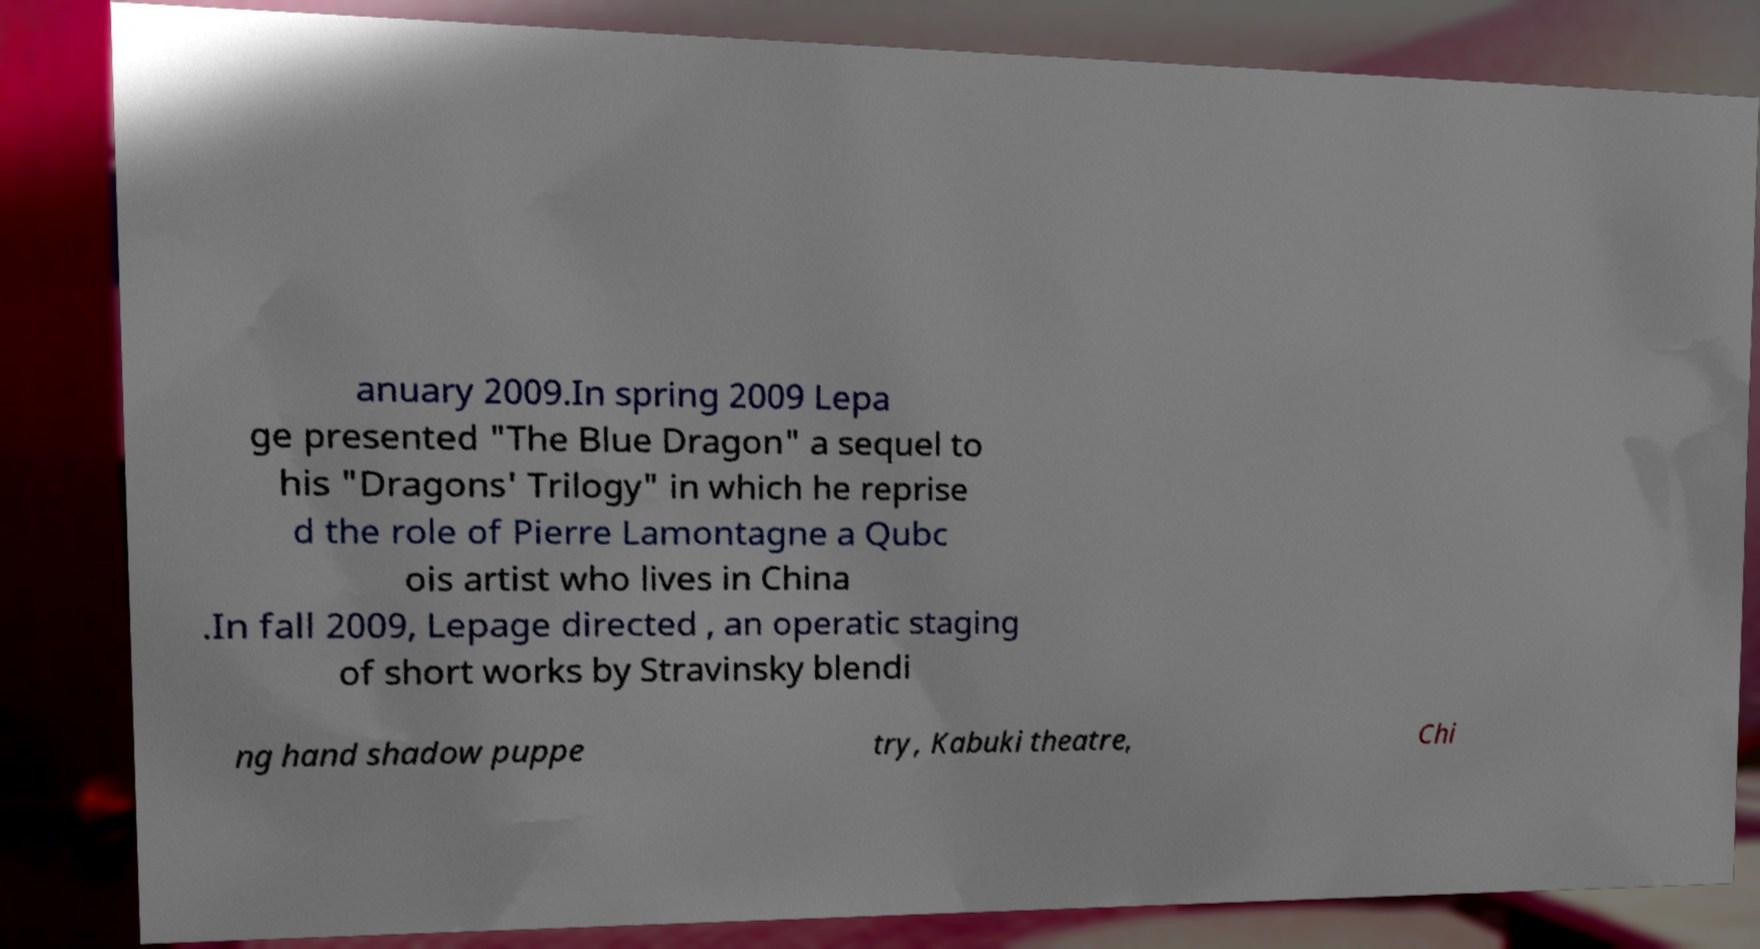Please identify and transcribe the text found in this image. anuary 2009.In spring 2009 Lepa ge presented "The Blue Dragon" a sequel to his "Dragons' Trilogy" in which he reprise d the role of Pierre Lamontagne a Qubc ois artist who lives in China .In fall 2009, Lepage directed , an operatic staging of short works by Stravinsky blendi ng hand shadow puppe try, Kabuki theatre, Chi 